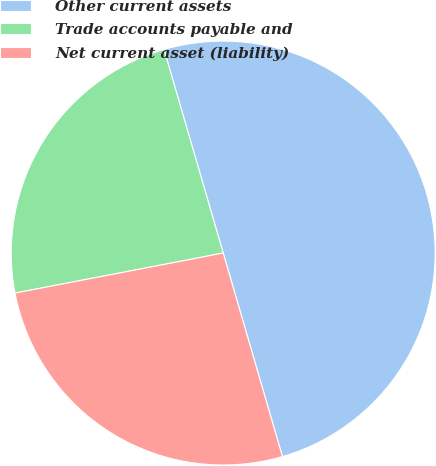<chart> <loc_0><loc_0><loc_500><loc_500><pie_chart><fcel>Other current assets<fcel>Trade accounts payable and<fcel>Net current asset (liability)<nl><fcel>50.0%<fcel>23.52%<fcel>26.48%<nl></chart> 